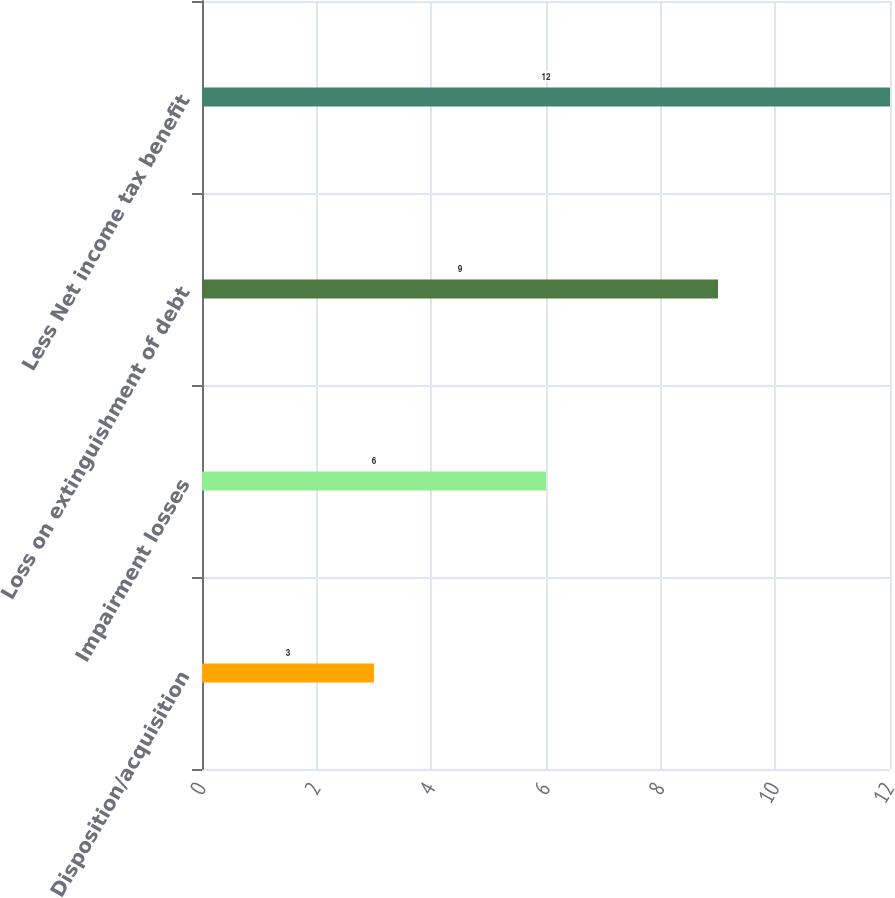Convert chart to OTSL. <chart><loc_0><loc_0><loc_500><loc_500><bar_chart><fcel>Disposition/acquisition<fcel>Impairment losses<fcel>Loss on extinguishment of debt<fcel>Less Net income tax benefit<nl><fcel>3<fcel>6<fcel>9<fcel>12<nl></chart> 